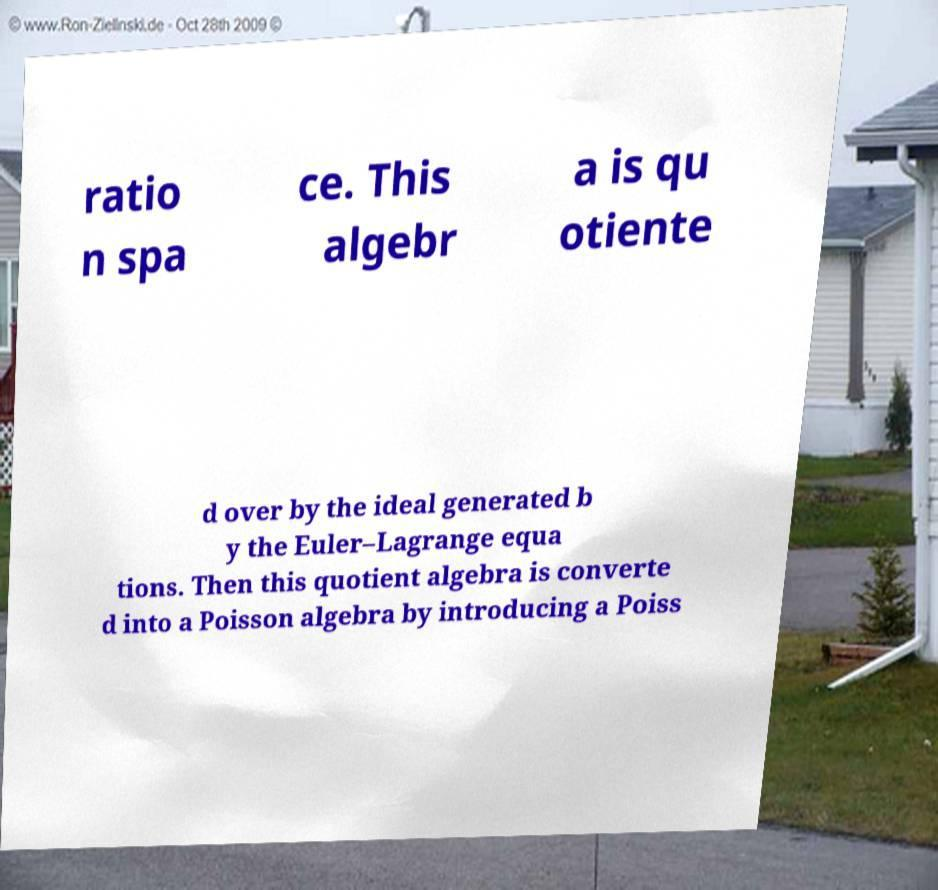Can you read and provide the text displayed in the image?This photo seems to have some interesting text. Can you extract and type it out for me? ratio n spa ce. This algebr a is qu otiente d over by the ideal generated b y the Euler–Lagrange equa tions. Then this quotient algebra is converte d into a Poisson algebra by introducing a Poiss 